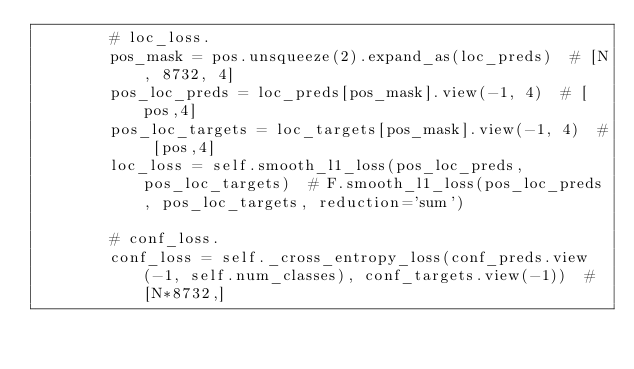<code> <loc_0><loc_0><loc_500><loc_500><_Python_>        # loc_loss.
        pos_mask = pos.unsqueeze(2).expand_as(loc_preds)  # [N, 8732, 4]
        pos_loc_preds = loc_preds[pos_mask].view(-1, 4)  # [pos,4]
        pos_loc_targets = loc_targets[pos_mask].view(-1, 4)  # [pos,4]
        loc_loss = self.smooth_l1_loss(pos_loc_preds, pos_loc_targets)  # F.smooth_l1_loss(pos_loc_preds, pos_loc_targets, reduction='sum')

        # conf_loss.
        conf_loss = self._cross_entropy_loss(conf_preds.view(-1, self.num_classes), conf_targets.view(-1))  # [N*8732,]</code> 